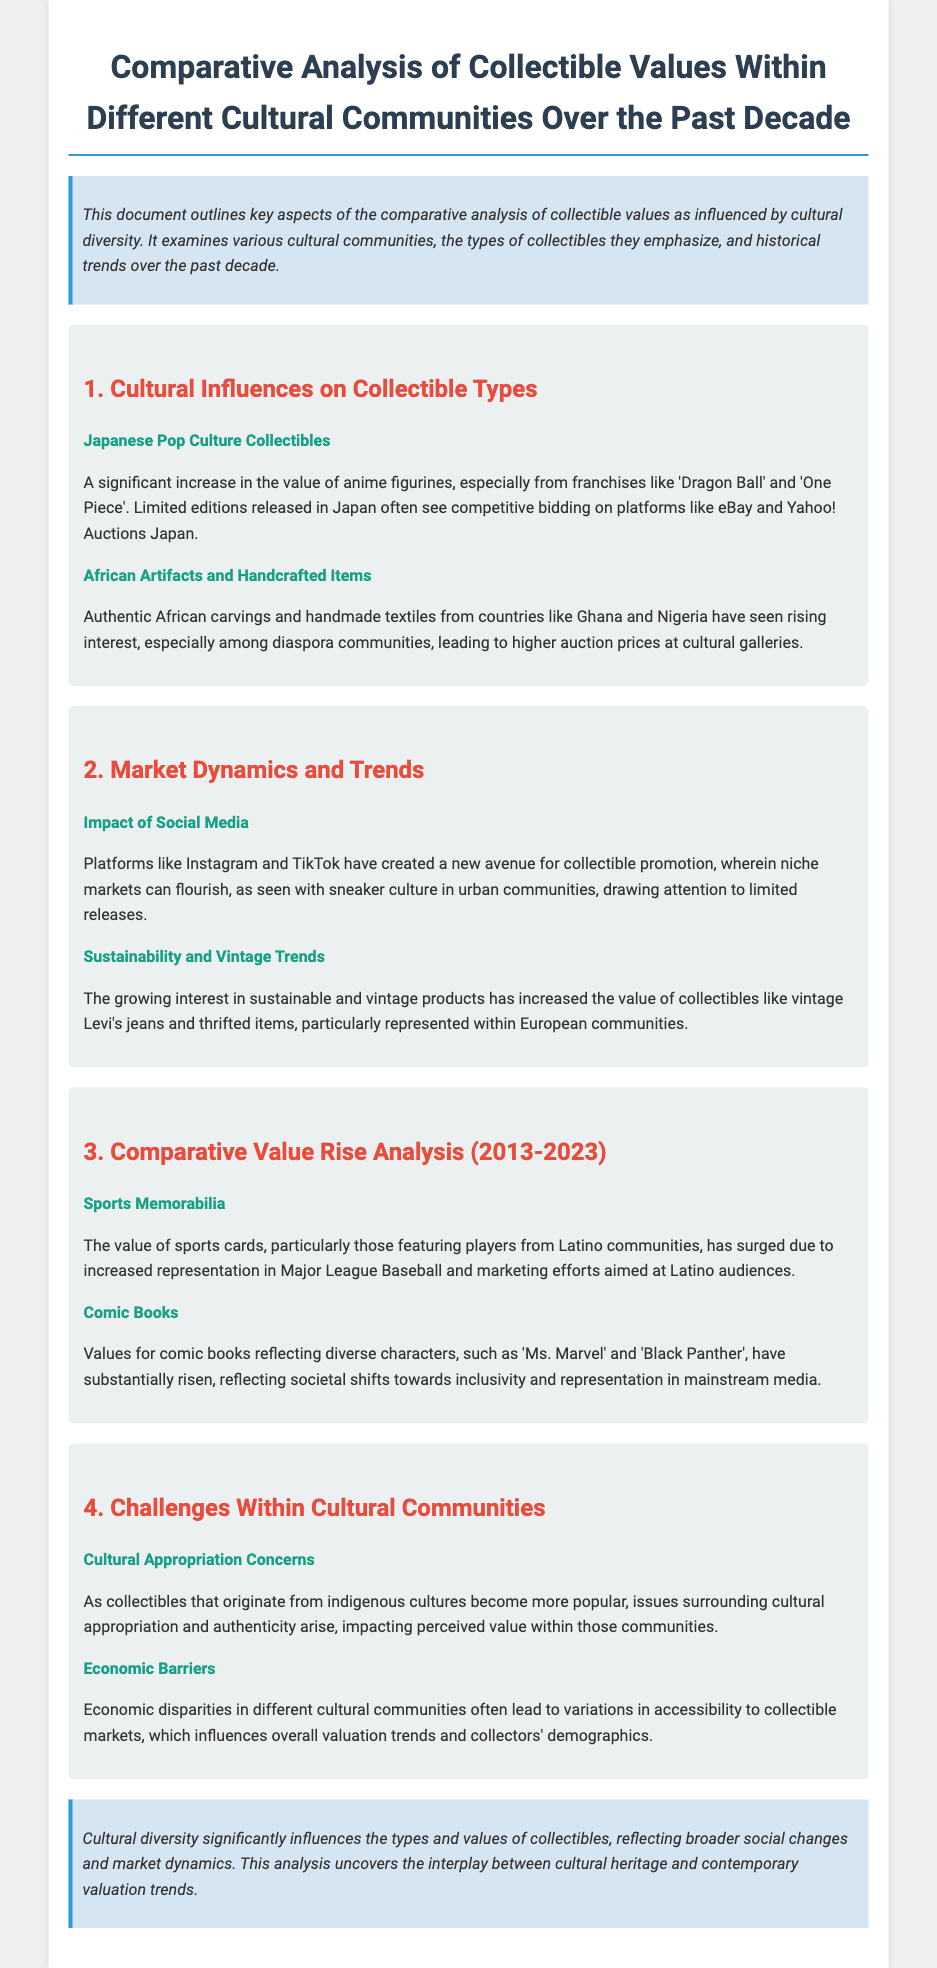What types of collectibles saw a rise in value from Japanese culture? The document mentions anime figurines, particularly from franchises like 'Dragon Ball' and 'One Piece'.
Answer: anime figurines Which African items have gained interest according to the document? Authentic African carvings and handmade textiles from countries like Ghana and Nigeria are highlighted in the document.
Answer: carvings and textiles What social media platforms are noted for promoting collectible culture? The document lists Instagram and TikTok as platforms that have created new avenues for collectible promotion.
Answer: Instagram and TikTok In which collectible category did values rise related to Latino communities? The document specifies sports cards, particularly those featuring players from Latino communities, as experiencing a surge in value.
Answer: sports cards What societal shift is reflected in the rising value of comic books? The document states that the values for comic books like 'Ms. Marvel' and 'Black Panther' have risen due to shifts towards inclusivity and representation in mainstream media.
Answer: inclusivity and representation What issue arises with the popularity of indigenous culture collectibles? Cultural appropriation concerns are mentioned as a challenge within cultural communities regarding the value of indigenous collectibles.
Answer: cultural appropriation What economic factor influences collectible market access? Economic disparities in different cultural communities impact accessibility, leading to variations in valuation trends.
Answer: economic disparities What has increased the value of vintage products in European communities? The growing interest in sustainable and vintage products has led to increased value, especially for items like vintage Levi's jeans.
Answer: sustainability What decade's trends are being analyzed in this document? The analysis focuses on trends within collectible values over the past decade, specifically from 2013 to 2023.
Answer: 2013 to 2023 